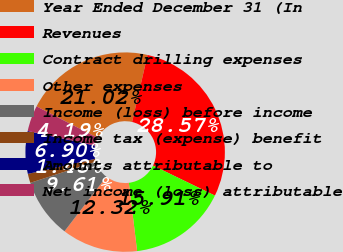Convert chart. <chart><loc_0><loc_0><loc_500><loc_500><pie_chart><fcel>Year Ended December 31 (In<fcel>Revenues<fcel>Contract drilling expenses<fcel>Other expenses<fcel>Income (loss) before income<fcel>Income tax (expense) benefit<fcel>Amounts attributable to<fcel>Net income (loss) attributable<nl><fcel>21.02%<fcel>28.57%<fcel>15.91%<fcel>12.32%<fcel>9.61%<fcel>1.48%<fcel>6.9%<fcel>4.19%<nl></chart> 